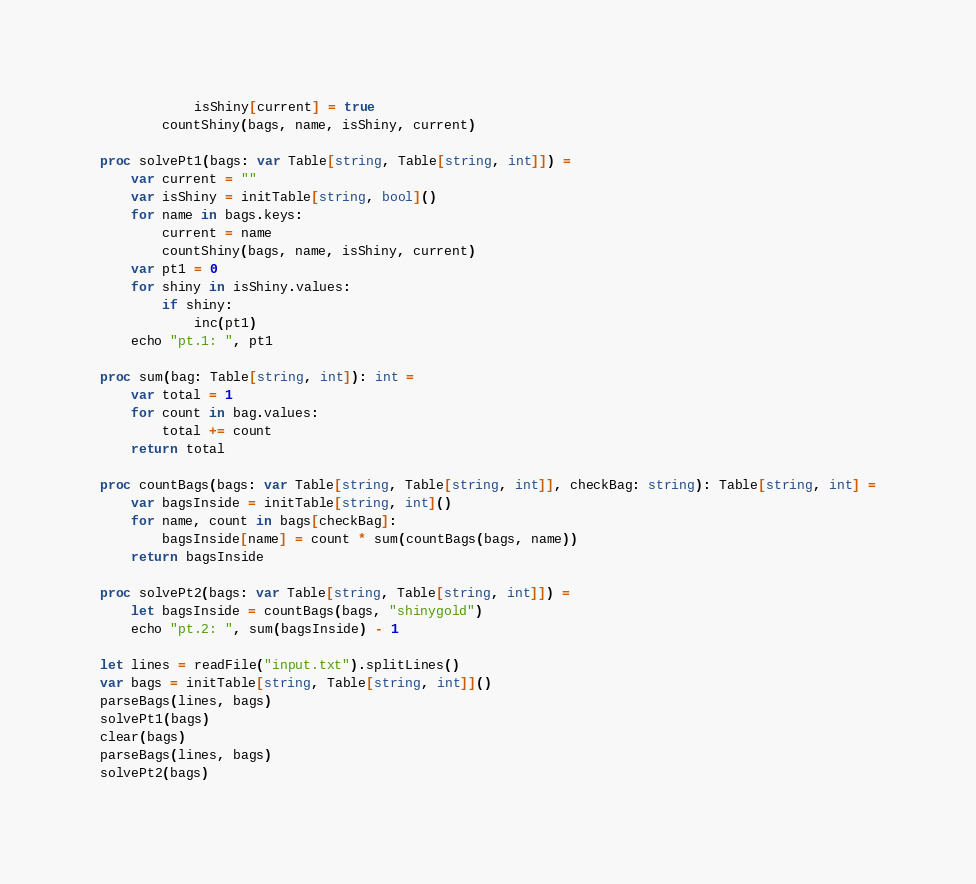<code> <loc_0><loc_0><loc_500><loc_500><_Nim_>            isShiny[current] = true
        countShiny(bags, name, isShiny, current)

proc solvePt1(bags: var Table[string, Table[string, int]]) =
    var current = ""
    var isShiny = initTable[string, bool]()
    for name in bags.keys:
        current = name
        countShiny(bags, name, isShiny, current)
    var pt1 = 0
    for shiny in isShiny.values:
        if shiny:
            inc(pt1)
    echo "pt.1: ", pt1

proc sum(bag: Table[string, int]): int =
    var total = 1
    for count in bag.values:
        total += count
    return total

proc countBags(bags: var Table[string, Table[string, int]], checkBag: string): Table[string, int] =
    var bagsInside = initTable[string, int]()
    for name, count in bags[checkBag]:
        bagsInside[name] = count * sum(countBags(bags, name))
    return bagsInside

proc solvePt2(bags: var Table[string, Table[string, int]]) =
    let bagsInside = countBags(bags, "shinygold")
    echo "pt.2: ", sum(bagsInside) - 1

let lines = readFile("input.txt").splitLines()
var bags = initTable[string, Table[string, int]]()
parseBags(lines, bags)
solvePt1(bags)
clear(bags)
parseBags(lines, bags)
solvePt2(bags)
</code> 